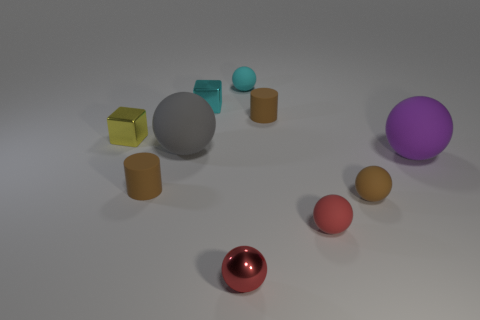Subtract all gray spheres. How many spheres are left? 5 Subtract all cyan rubber spheres. How many spheres are left? 5 Subtract all gray balls. Subtract all purple blocks. How many balls are left? 5 Subtract all spheres. How many objects are left? 4 Add 1 large gray shiny objects. How many large gray shiny objects exist? 1 Subtract 1 purple balls. How many objects are left? 9 Subtract all small gray metal cylinders. Subtract all yellow metallic blocks. How many objects are left? 9 Add 5 tiny matte spheres. How many tiny matte spheres are left? 8 